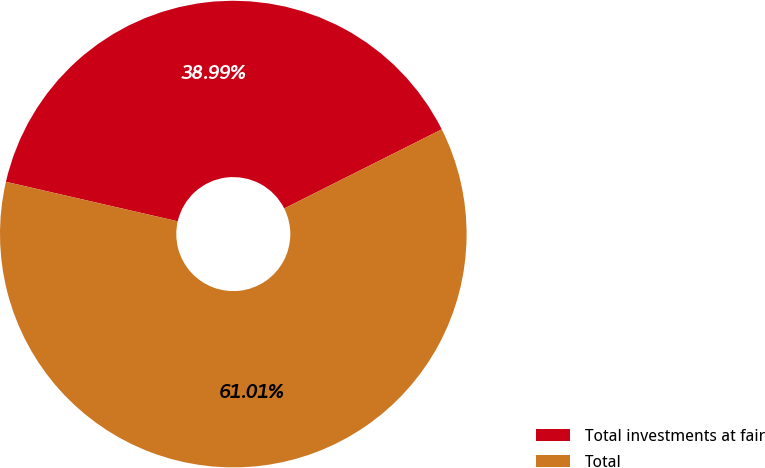<chart> <loc_0><loc_0><loc_500><loc_500><pie_chart><fcel>Total investments at fair<fcel>Total<nl><fcel>38.99%<fcel>61.01%<nl></chart> 